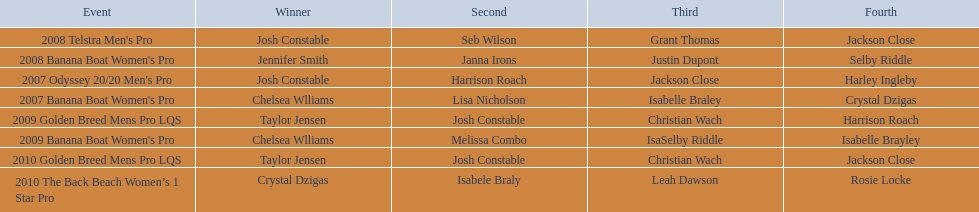How many times did josh constable triumph after 2007? 1. Could you parse the entire table? {'header': ['Event', 'Winner', 'Second', 'Third', 'Fourth'], 'rows': [["2008 Telstra Men's Pro", 'Josh Constable', 'Seb Wilson', 'Grant Thomas', 'Jackson Close'], ["2008 Banana Boat Women's Pro", 'Jennifer Smith', 'Janna Irons', 'Justin Dupont', 'Selby Riddle'], ["2007 Odyssey 20/20 Men's Pro", 'Josh Constable', 'Harrison Roach', 'Jackson Close', 'Harley Ingleby'], ["2007 Banana Boat Women's Pro", 'Chelsea Wlliams', 'Lisa Nicholson', 'Isabelle Braley', 'Crystal Dzigas'], ['2009 Golden Breed Mens Pro LQS', 'Taylor Jensen', 'Josh Constable', 'Christian Wach', 'Harrison Roach'], ["2009 Banana Boat Women's Pro", 'Chelsea Wlliams', 'Melissa Combo', 'IsaSelby Riddle', 'Isabelle Brayley'], ['2010 Golden Breed Mens Pro LQS', 'Taylor Jensen', 'Josh Constable', 'Christian Wach', 'Jackson Close'], ['2010 The Back Beach Women’s 1 Star Pro', 'Crystal Dzigas', 'Isabele Braly', 'Leah Dawson', 'Rosie Locke']]} 